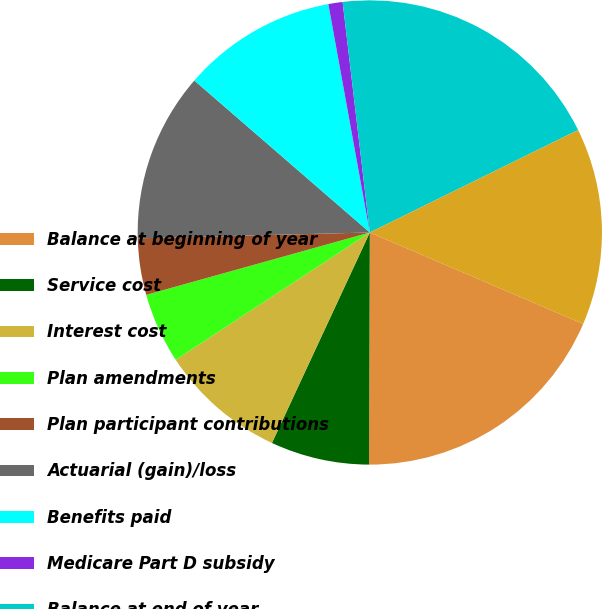Convert chart. <chart><loc_0><loc_0><loc_500><loc_500><pie_chart><fcel>Balance at beginning of year<fcel>Service cost<fcel>Interest cost<fcel>Plan amendments<fcel>Plan participant contributions<fcel>Actuarial (gain)/loss<fcel>Benefits paid<fcel>Medicare Part D subsidy<fcel>Balance at end of year<fcel>Fair value of assets at<nl><fcel>18.61%<fcel>6.87%<fcel>8.83%<fcel>4.91%<fcel>3.93%<fcel>11.76%<fcel>10.78%<fcel>0.99%<fcel>19.59%<fcel>13.72%<nl></chart> 